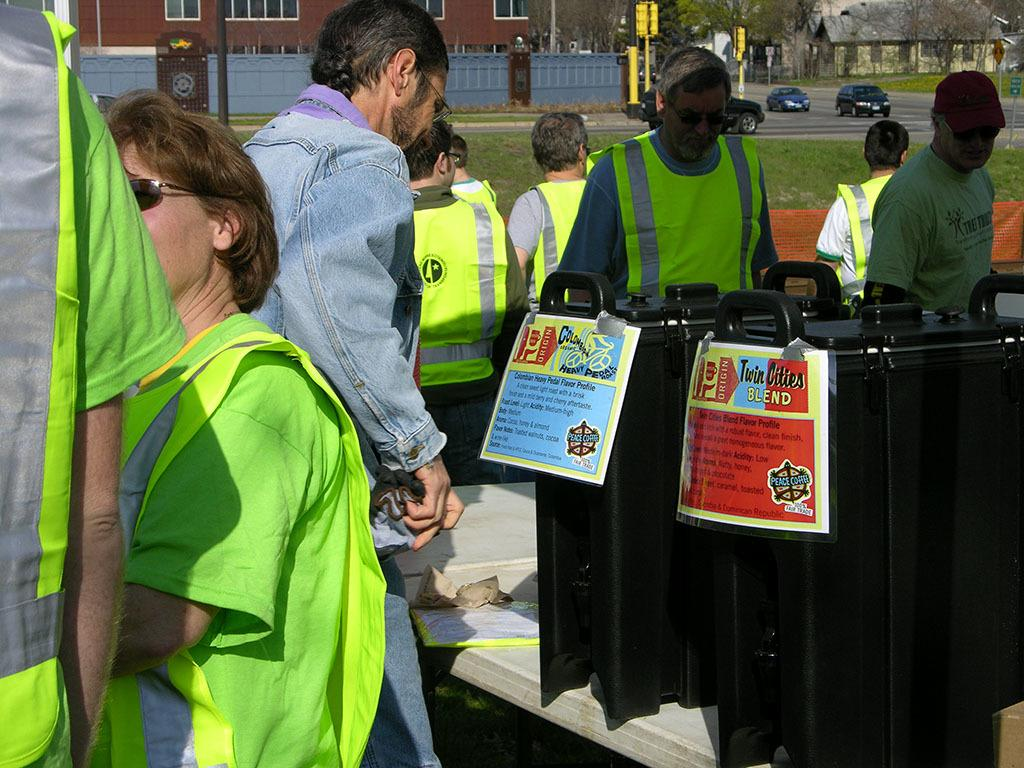<image>
Share a concise interpretation of the image provided. A sign that has Twin Cities Blend written on it. 